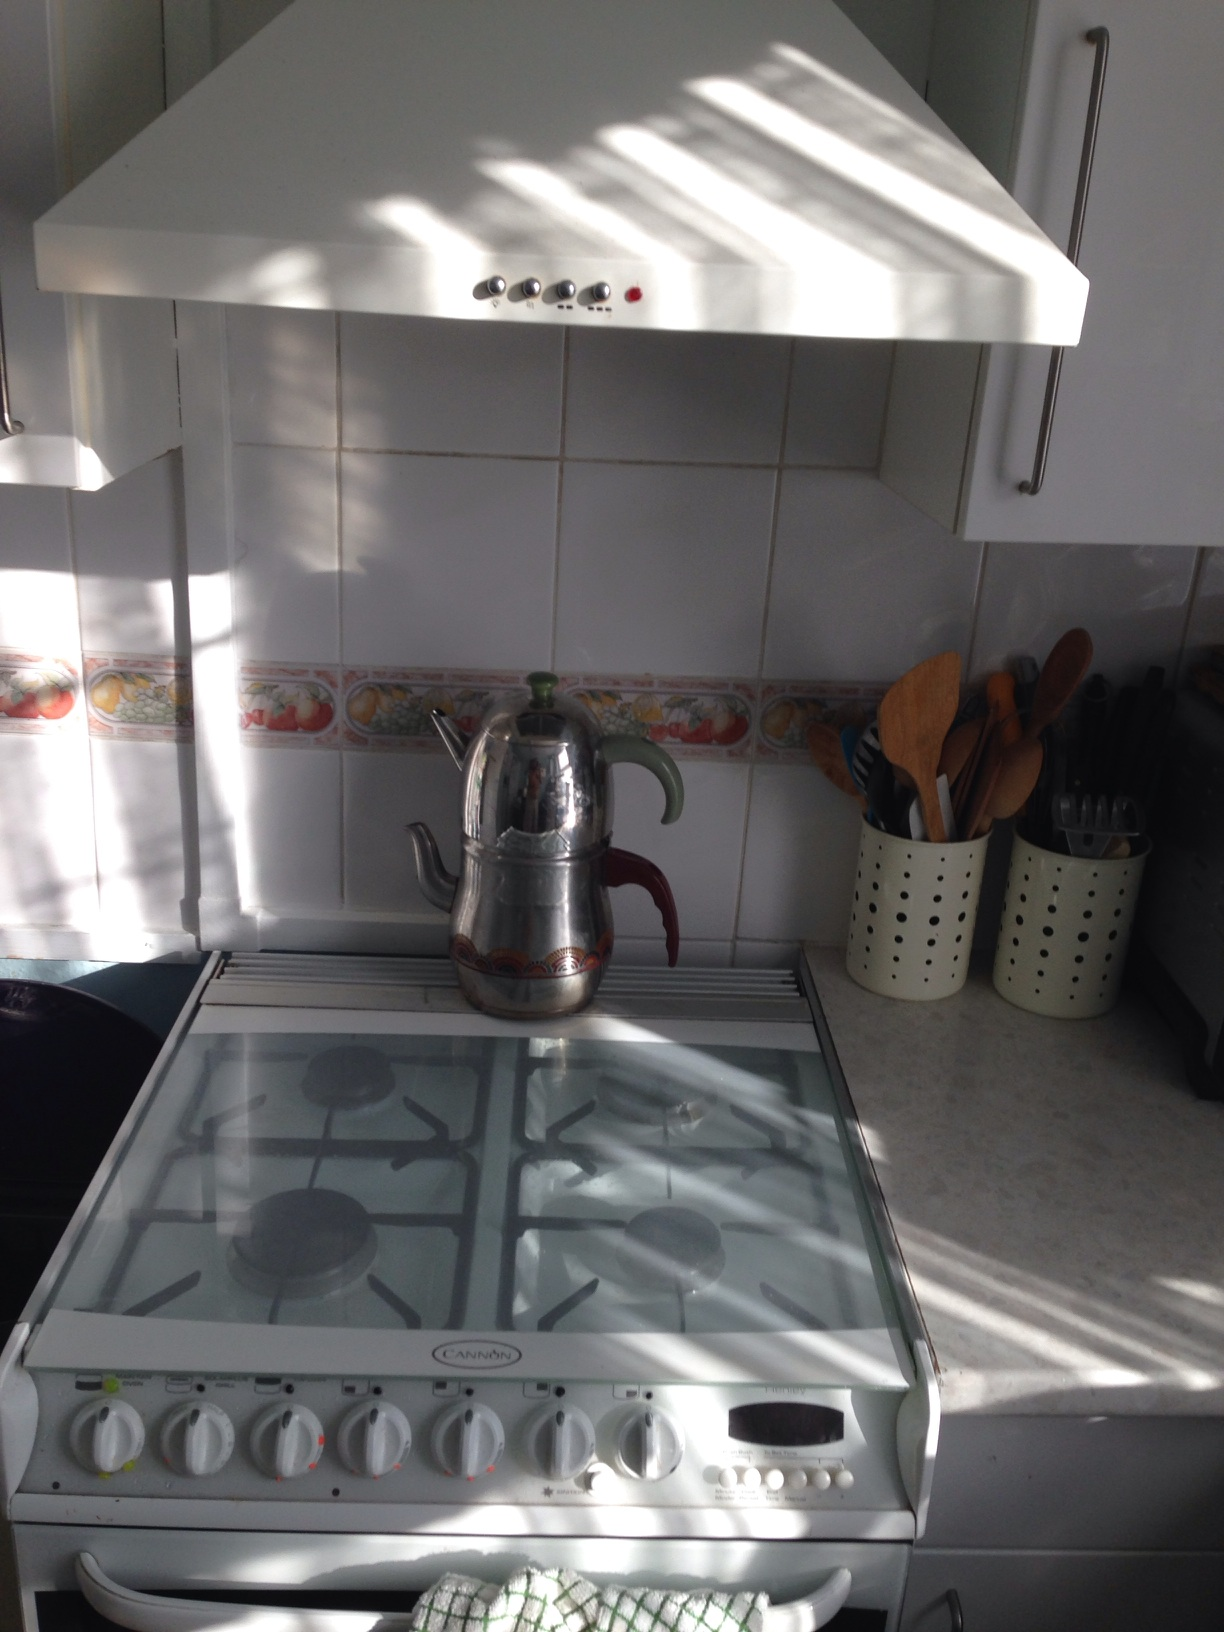What kind of meal do you think is being prepared here? It looks like a traditional meal might be getting prepared here, possibly involving tea given the teapot on the stove. Perhaps a warming soup or a stew is in the works on this cozy day. 